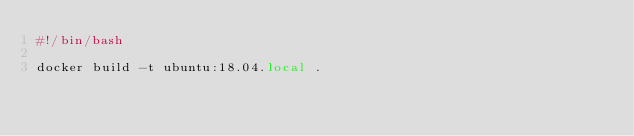<code> <loc_0><loc_0><loc_500><loc_500><_Bash_>#!/bin/bash

docker build -t ubuntu:18.04.local .
</code> 